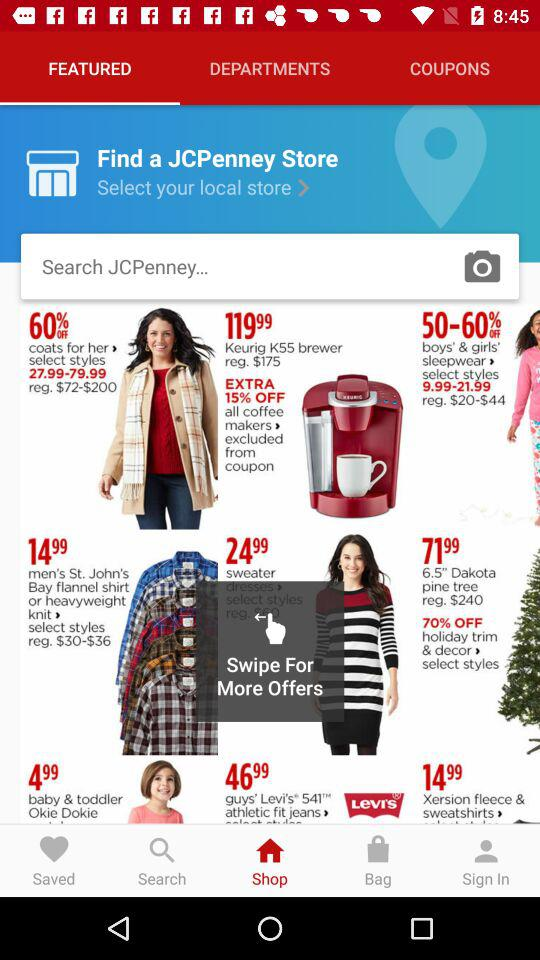Which tab is selected? The selected tab is "FEATURED". 